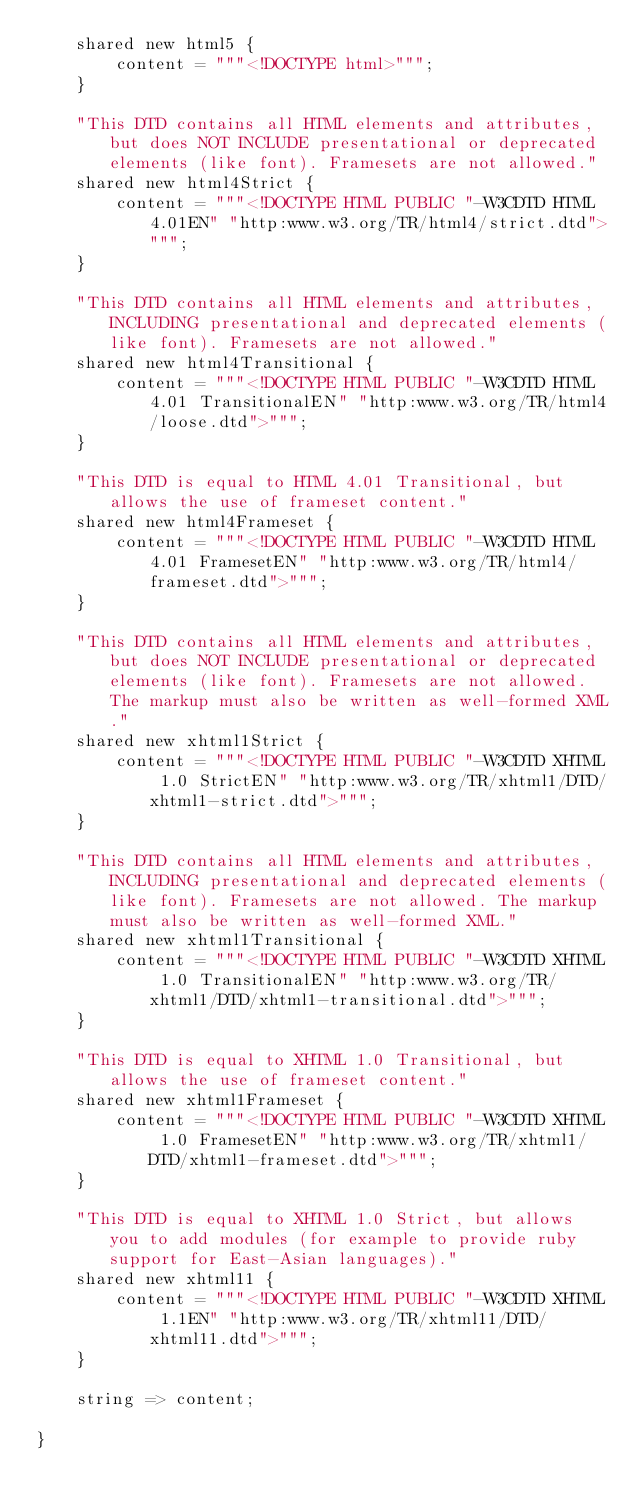Convert code to text. <code><loc_0><loc_0><loc_500><loc_500><_Ceylon_>    shared new html5 {
        content = """<!DOCTYPE html>""";
    }
    
    "This DTD contains all HTML elements and attributes, but does NOT INCLUDE presentational or deprecated elements (like font). Framesets are not allowed."
    shared new html4Strict {
        content = """<!DOCTYPE HTML PUBLIC "-W3CDTD HTML 4.01EN" "http:www.w3.org/TR/html4/strict.dtd">""";
    }
    
    "This DTD contains all HTML elements and attributes, INCLUDING presentational and deprecated elements (like font). Framesets are not allowed."
    shared new html4Transitional {
        content = """<!DOCTYPE HTML PUBLIC "-W3CDTD HTML 4.01 TransitionalEN" "http:www.w3.org/TR/html4/loose.dtd">""";
    }
    
    "This DTD is equal to HTML 4.01 Transitional, but allows the use of frameset content."
    shared new html4Frameset {
        content = """<!DOCTYPE HTML PUBLIC "-W3CDTD HTML 4.01 FramesetEN" "http:www.w3.org/TR/html4/frameset.dtd">""";
    }
    
    "This DTD contains all HTML elements and attributes, but does NOT INCLUDE presentational or deprecated elements (like font). Framesets are not allowed. The markup must also be written as well-formed XML."
    shared new xhtml1Strict {
        content = """<!DOCTYPE HTML PUBLIC "-W3CDTD XHTML 1.0 StrictEN" "http:www.w3.org/TR/xhtml1/DTD/xhtml1-strict.dtd">""";
    }
    
    "This DTD contains all HTML elements and attributes, INCLUDING presentational and deprecated elements (like font). Framesets are not allowed. The markup must also be written as well-formed XML."
    shared new xhtml1Transitional {
        content = """<!DOCTYPE HTML PUBLIC "-W3CDTD XHTML 1.0 TransitionalEN" "http:www.w3.org/TR/xhtml1/DTD/xhtml1-transitional.dtd">""";
    }
    
    "This DTD is equal to XHTML 1.0 Transitional, but allows the use of frameset content."
    shared new xhtml1Frameset {
        content = """<!DOCTYPE HTML PUBLIC "-W3CDTD XHTML 1.0 FramesetEN" "http:www.w3.org/TR/xhtml1/DTD/xhtml1-frameset.dtd">""";
    }
    
    "This DTD is equal to XHTML 1.0 Strict, but allows you to add modules (for example to provide ruby support for East-Asian languages)."
    shared new xhtml11 {
        content = """<!DOCTYPE HTML PUBLIC "-W3CDTD XHTML 1.1EN" "http:www.w3.org/TR/xhtml11/DTD/xhtml11.dtd">""";
    }
    
    string => content;
    
}</code> 